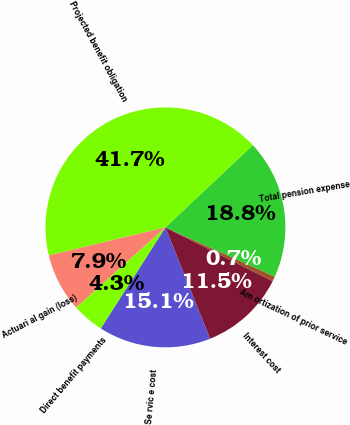Convert chart. <chart><loc_0><loc_0><loc_500><loc_500><pie_chart><fcel>Se rvic e cost<fcel>Interest cost<fcel>Am ortization of prior service<fcel>Total pension expense<fcel>Projected benefit obligation<fcel>Actuari al gain (loss)<fcel>Direct benefit payments<nl><fcel>15.14%<fcel>11.52%<fcel>0.66%<fcel>18.76%<fcel>41.74%<fcel>7.9%<fcel>4.28%<nl></chart> 